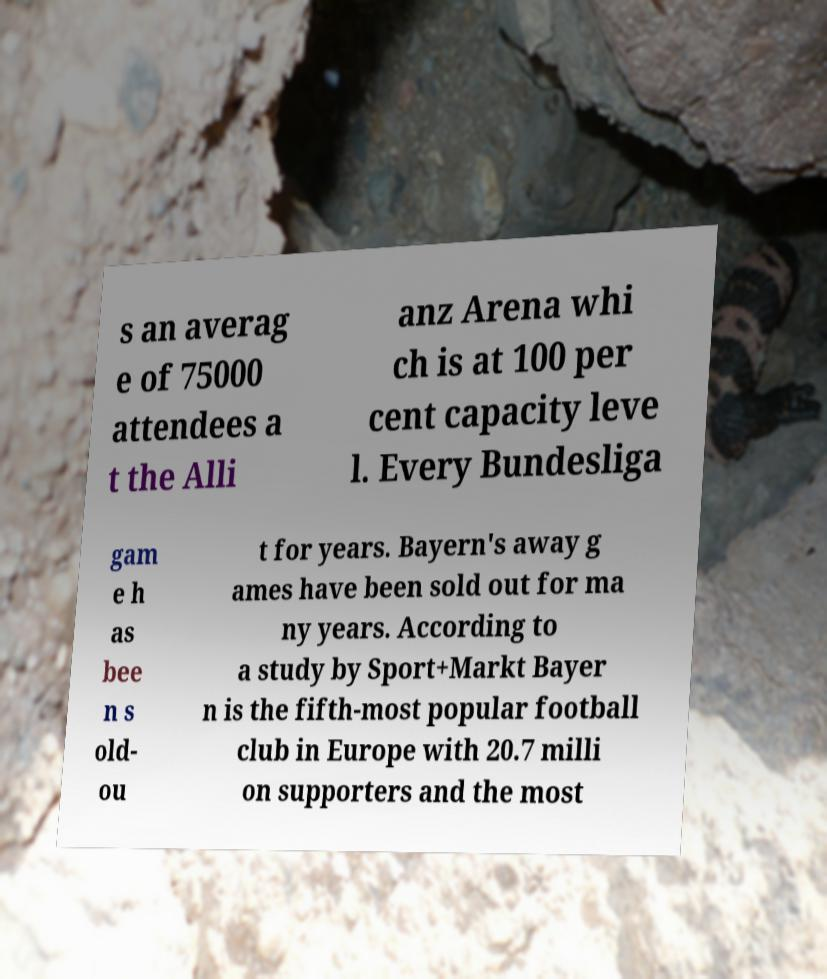What messages or text are displayed in this image? I need them in a readable, typed format. s an averag e of 75000 attendees a t the Alli anz Arena whi ch is at 100 per cent capacity leve l. Every Bundesliga gam e h as bee n s old- ou t for years. Bayern's away g ames have been sold out for ma ny years. According to a study by Sport+Markt Bayer n is the fifth-most popular football club in Europe with 20.7 milli on supporters and the most 